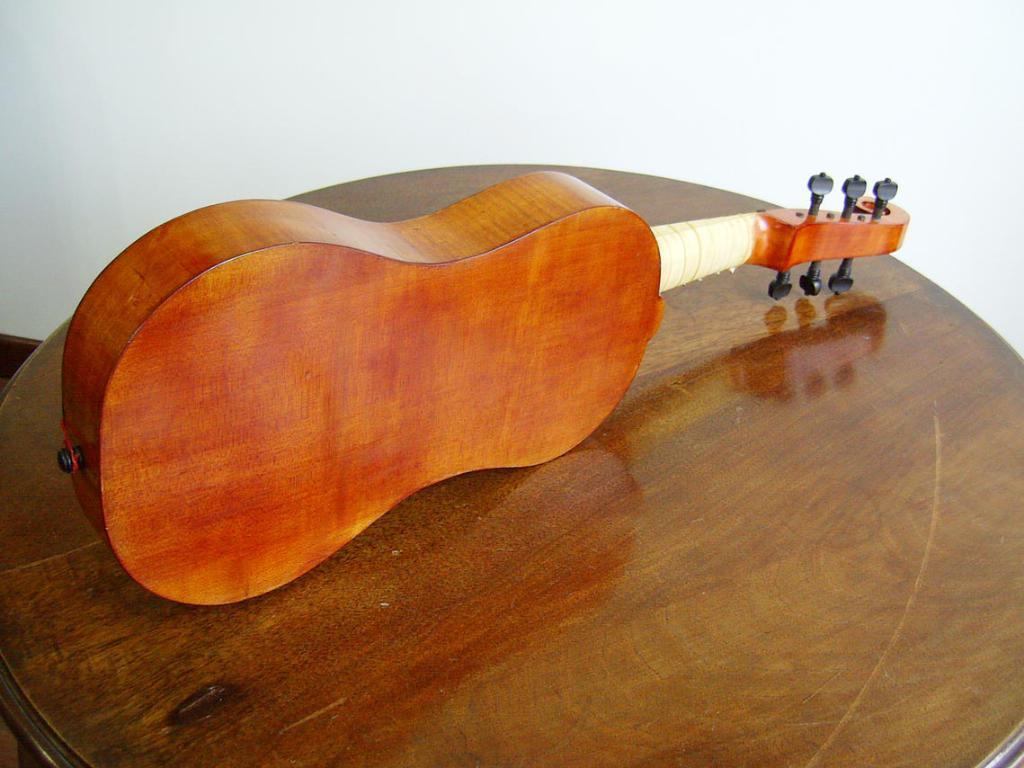Could you give a brief overview of what you see in this image? In this image I can see the backside of a violin. This is violin is like an wooden texture. This is placed on the table. And this looks like a wall which is white in color. 